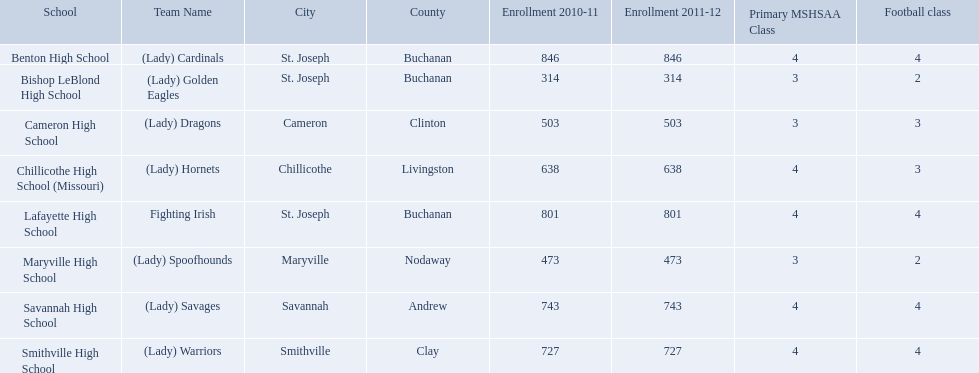What are the three schools in the town of st. joseph? St. Joseph, St. Joseph, St. Joseph. Of the three schools in st. joseph which school's team name does not depict a type of animal? Lafayette High School. What were the schools enrolled in 2010-2011 Benton High School, Bishop LeBlond High School, Cameron High School, Chillicothe High School (Missouri), Lafayette High School, Maryville High School, Savannah High School, Smithville High School. How many were enrolled in each? 846, 314, 503, 638, 801, 473, 743, 727. Which is the lowest number? 314. Which school had this number of students? Bishop LeBlond High School. 